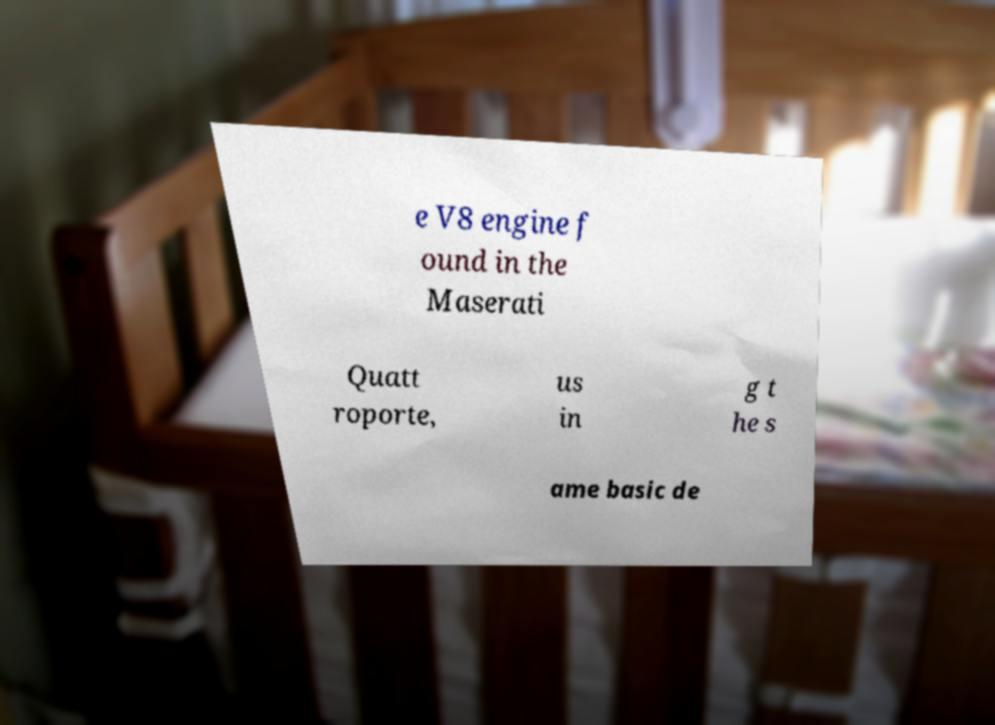Please identify and transcribe the text found in this image. e V8 engine f ound in the Maserati Quatt roporte, us in g t he s ame basic de 